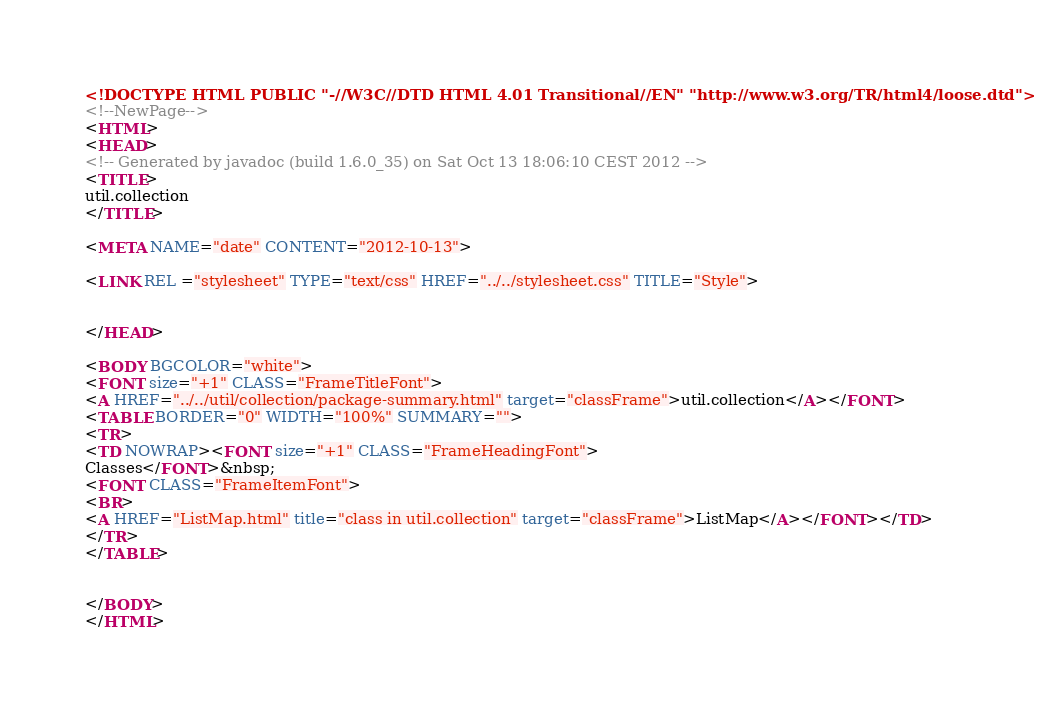Convert code to text. <code><loc_0><loc_0><loc_500><loc_500><_HTML_><!DOCTYPE HTML PUBLIC "-//W3C//DTD HTML 4.01 Transitional//EN" "http://www.w3.org/TR/html4/loose.dtd">
<!--NewPage-->
<HTML>
<HEAD>
<!-- Generated by javadoc (build 1.6.0_35) on Sat Oct 13 18:06:10 CEST 2012 -->
<TITLE>
util.collection
</TITLE>

<META NAME="date" CONTENT="2012-10-13">

<LINK REL ="stylesheet" TYPE="text/css" HREF="../../stylesheet.css" TITLE="Style">


</HEAD>

<BODY BGCOLOR="white">
<FONT size="+1" CLASS="FrameTitleFont">
<A HREF="../../util/collection/package-summary.html" target="classFrame">util.collection</A></FONT>
<TABLE BORDER="0" WIDTH="100%" SUMMARY="">
<TR>
<TD NOWRAP><FONT size="+1" CLASS="FrameHeadingFont">
Classes</FONT>&nbsp;
<FONT CLASS="FrameItemFont">
<BR>
<A HREF="ListMap.html" title="class in util.collection" target="classFrame">ListMap</A></FONT></TD>
</TR>
</TABLE>


</BODY>
</HTML>
</code> 